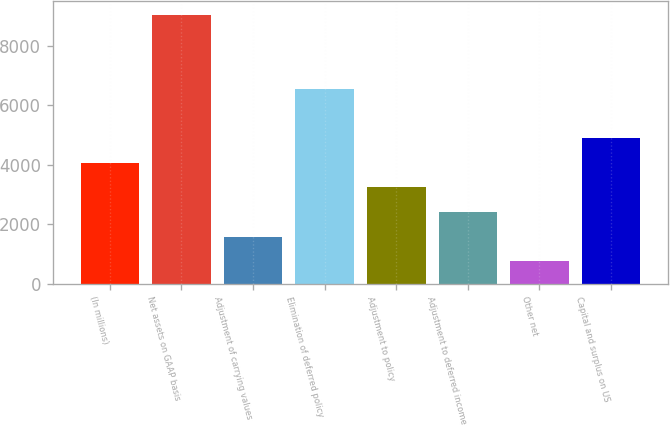Convert chart to OTSL. <chart><loc_0><loc_0><loc_500><loc_500><bar_chart><fcel>(In millions)<fcel>Net assets on GAAP basis<fcel>Adjustment of carrying values<fcel>Elimination of deferred policy<fcel>Adjustment to policy<fcel>Adjustment to deferred income<fcel>Other net<fcel>Capital and surplus on US<nl><fcel>4076<fcel>9050<fcel>1589<fcel>6540<fcel>3247<fcel>2418<fcel>760<fcel>4905<nl></chart> 